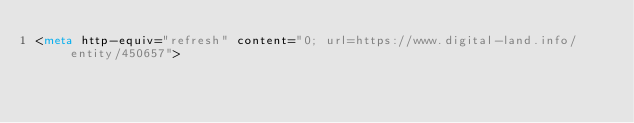<code> <loc_0><loc_0><loc_500><loc_500><_HTML_><meta http-equiv="refresh" content="0; url=https://www.digital-land.info/entity/450657"></code> 